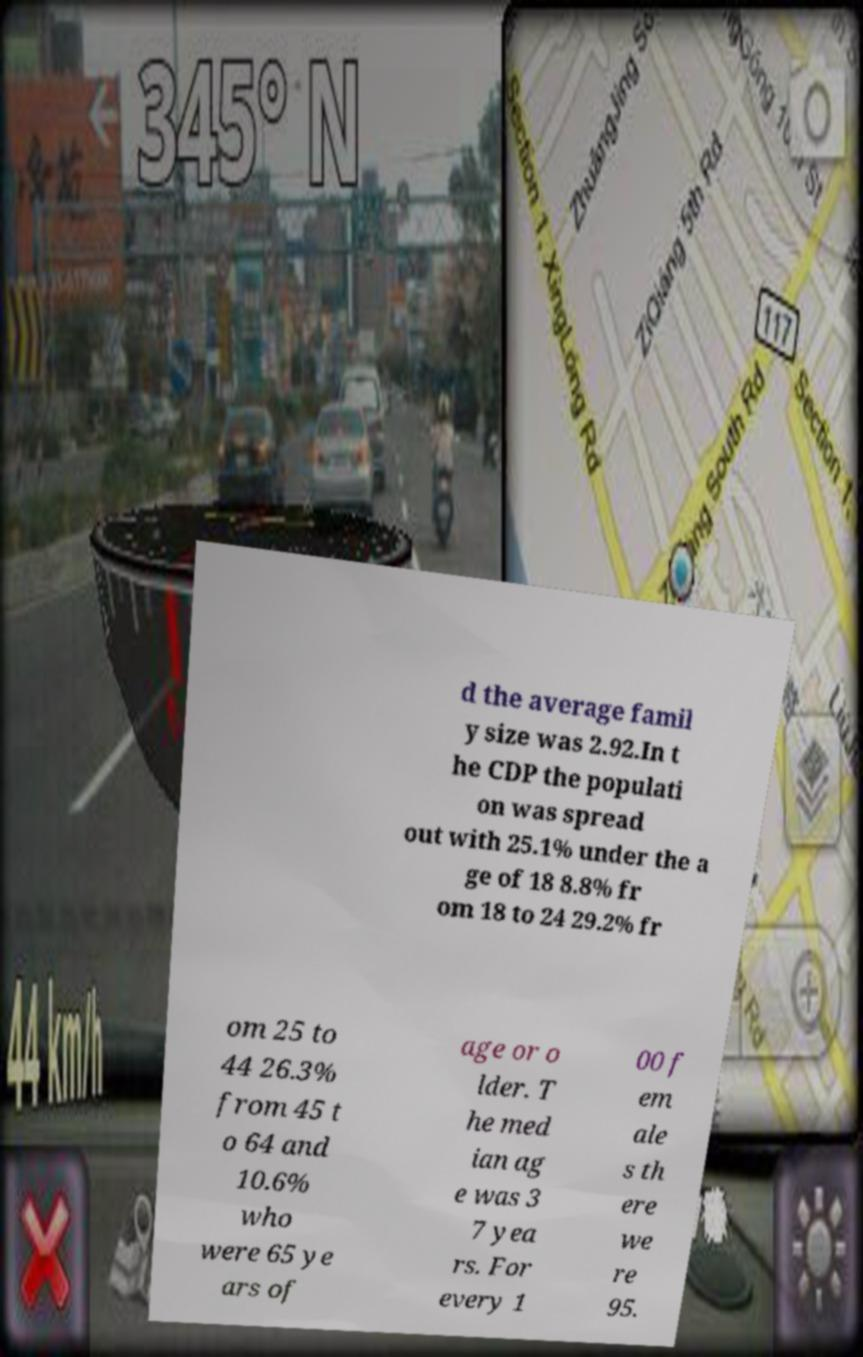Can you read and provide the text displayed in the image?This photo seems to have some interesting text. Can you extract and type it out for me? d the average famil y size was 2.92.In t he CDP the populati on was spread out with 25.1% under the a ge of 18 8.8% fr om 18 to 24 29.2% fr om 25 to 44 26.3% from 45 t o 64 and 10.6% who were 65 ye ars of age or o lder. T he med ian ag e was 3 7 yea rs. For every 1 00 f em ale s th ere we re 95. 